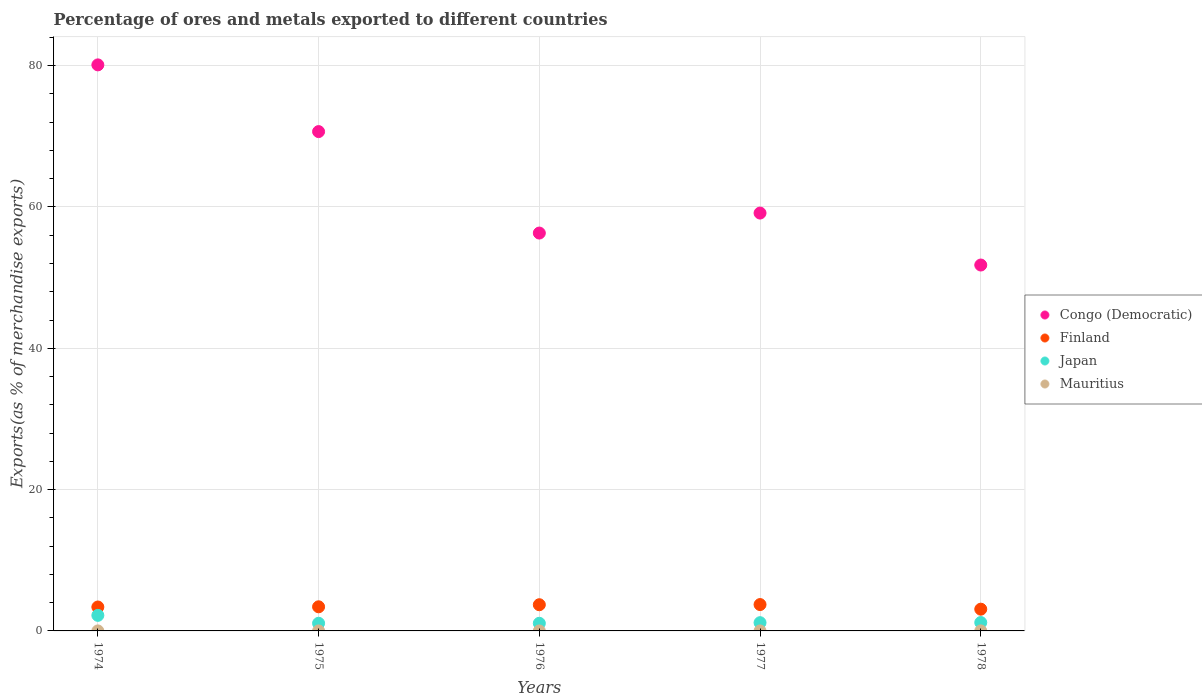Is the number of dotlines equal to the number of legend labels?
Your response must be concise. Yes. What is the percentage of exports to different countries in Finland in 1977?
Offer a very short reply. 3.73. Across all years, what is the maximum percentage of exports to different countries in Congo (Democratic)?
Offer a very short reply. 80.11. Across all years, what is the minimum percentage of exports to different countries in Congo (Democratic)?
Ensure brevity in your answer.  51.79. In which year was the percentage of exports to different countries in Finland minimum?
Your answer should be very brief. 1978. What is the total percentage of exports to different countries in Mauritius in the graph?
Offer a very short reply. 0.01. What is the difference between the percentage of exports to different countries in Finland in 1974 and that in 1975?
Your response must be concise. -0.03. What is the difference between the percentage of exports to different countries in Finland in 1975 and the percentage of exports to different countries in Congo (Democratic) in 1976?
Keep it short and to the point. -52.9. What is the average percentage of exports to different countries in Mauritius per year?
Your answer should be compact. 0. In the year 1977, what is the difference between the percentage of exports to different countries in Mauritius and percentage of exports to different countries in Congo (Democratic)?
Ensure brevity in your answer.  -59.14. What is the ratio of the percentage of exports to different countries in Mauritius in 1974 to that in 1977?
Offer a terse response. 0.18. Is the difference between the percentage of exports to different countries in Mauritius in 1974 and 1976 greater than the difference between the percentage of exports to different countries in Congo (Democratic) in 1974 and 1976?
Keep it short and to the point. No. What is the difference between the highest and the second highest percentage of exports to different countries in Japan?
Provide a short and direct response. 1.01. What is the difference between the highest and the lowest percentage of exports to different countries in Mauritius?
Keep it short and to the point. 0. Is the sum of the percentage of exports to different countries in Finland in 1975 and 1978 greater than the maximum percentage of exports to different countries in Japan across all years?
Your answer should be compact. Yes. Is it the case that in every year, the sum of the percentage of exports to different countries in Japan and percentage of exports to different countries in Finland  is greater than the sum of percentage of exports to different countries in Mauritius and percentage of exports to different countries in Congo (Democratic)?
Your answer should be compact. No. Is it the case that in every year, the sum of the percentage of exports to different countries in Finland and percentage of exports to different countries in Congo (Democratic)  is greater than the percentage of exports to different countries in Mauritius?
Your answer should be very brief. Yes. Does the percentage of exports to different countries in Japan monotonically increase over the years?
Make the answer very short. No. Is the percentage of exports to different countries in Congo (Democratic) strictly less than the percentage of exports to different countries in Japan over the years?
Your response must be concise. No. How many dotlines are there?
Give a very brief answer. 4. How many years are there in the graph?
Offer a terse response. 5. Are the values on the major ticks of Y-axis written in scientific E-notation?
Offer a very short reply. No. Does the graph contain any zero values?
Offer a terse response. No. Does the graph contain grids?
Provide a short and direct response. Yes. Where does the legend appear in the graph?
Give a very brief answer. Center right. What is the title of the graph?
Keep it short and to the point. Percentage of ores and metals exported to different countries. What is the label or title of the Y-axis?
Your answer should be compact. Exports(as % of merchandise exports). What is the Exports(as % of merchandise exports) of Congo (Democratic) in 1974?
Make the answer very short. 80.11. What is the Exports(as % of merchandise exports) of Finland in 1974?
Keep it short and to the point. 3.39. What is the Exports(as % of merchandise exports) of Japan in 1974?
Provide a short and direct response. 2.2. What is the Exports(as % of merchandise exports) in Mauritius in 1974?
Give a very brief answer. 0. What is the Exports(as % of merchandise exports) of Congo (Democratic) in 1975?
Your answer should be compact. 70.67. What is the Exports(as % of merchandise exports) of Finland in 1975?
Offer a terse response. 3.41. What is the Exports(as % of merchandise exports) in Japan in 1975?
Make the answer very short. 1.08. What is the Exports(as % of merchandise exports) in Mauritius in 1975?
Your answer should be compact. 0. What is the Exports(as % of merchandise exports) of Congo (Democratic) in 1976?
Ensure brevity in your answer.  56.31. What is the Exports(as % of merchandise exports) of Finland in 1976?
Provide a short and direct response. 3.71. What is the Exports(as % of merchandise exports) in Japan in 1976?
Provide a short and direct response. 1.08. What is the Exports(as % of merchandise exports) of Mauritius in 1976?
Give a very brief answer. 1.50016651848355e-5. What is the Exports(as % of merchandise exports) of Congo (Democratic) in 1977?
Offer a terse response. 59.14. What is the Exports(as % of merchandise exports) in Finland in 1977?
Provide a succinct answer. 3.73. What is the Exports(as % of merchandise exports) in Japan in 1977?
Your response must be concise. 1.17. What is the Exports(as % of merchandise exports) in Mauritius in 1977?
Your answer should be very brief. 0. What is the Exports(as % of merchandise exports) in Congo (Democratic) in 1978?
Provide a succinct answer. 51.79. What is the Exports(as % of merchandise exports) of Finland in 1978?
Offer a very short reply. 3.08. What is the Exports(as % of merchandise exports) of Japan in 1978?
Provide a succinct answer. 1.19. What is the Exports(as % of merchandise exports) in Mauritius in 1978?
Offer a terse response. 0. Across all years, what is the maximum Exports(as % of merchandise exports) of Congo (Democratic)?
Give a very brief answer. 80.11. Across all years, what is the maximum Exports(as % of merchandise exports) in Finland?
Offer a very short reply. 3.73. Across all years, what is the maximum Exports(as % of merchandise exports) of Japan?
Your answer should be very brief. 2.2. Across all years, what is the maximum Exports(as % of merchandise exports) of Mauritius?
Offer a terse response. 0. Across all years, what is the minimum Exports(as % of merchandise exports) of Congo (Democratic)?
Keep it short and to the point. 51.79. Across all years, what is the minimum Exports(as % of merchandise exports) in Finland?
Provide a short and direct response. 3.08. Across all years, what is the minimum Exports(as % of merchandise exports) of Japan?
Offer a very short reply. 1.08. Across all years, what is the minimum Exports(as % of merchandise exports) in Mauritius?
Give a very brief answer. 1.50016651848355e-5. What is the total Exports(as % of merchandise exports) of Congo (Democratic) in the graph?
Provide a succinct answer. 318.03. What is the total Exports(as % of merchandise exports) in Finland in the graph?
Offer a terse response. 17.32. What is the total Exports(as % of merchandise exports) in Japan in the graph?
Offer a terse response. 6.72. What is the total Exports(as % of merchandise exports) in Mauritius in the graph?
Ensure brevity in your answer.  0.01. What is the difference between the Exports(as % of merchandise exports) in Congo (Democratic) in 1974 and that in 1975?
Your response must be concise. 9.44. What is the difference between the Exports(as % of merchandise exports) in Finland in 1974 and that in 1975?
Your answer should be compact. -0.03. What is the difference between the Exports(as % of merchandise exports) of Japan in 1974 and that in 1975?
Ensure brevity in your answer.  1.12. What is the difference between the Exports(as % of merchandise exports) in Mauritius in 1974 and that in 1975?
Provide a succinct answer. 0. What is the difference between the Exports(as % of merchandise exports) of Congo (Democratic) in 1974 and that in 1976?
Your response must be concise. 23.8. What is the difference between the Exports(as % of merchandise exports) of Finland in 1974 and that in 1976?
Offer a terse response. -0.32. What is the difference between the Exports(as % of merchandise exports) in Japan in 1974 and that in 1976?
Provide a short and direct response. 1.12. What is the difference between the Exports(as % of merchandise exports) in Mauritius in 1974 and that in 1976?
Your response must be concise. 0. What is the difference between the Exports(as % of merchandise exports) of Congo (Democratic) in 1974 and that in 1977?
Offer a terse response. 20.97. What is the difference between the Exports(as % of merchandise exports) in Finland in 1974 and that in 1977?
Offer a terse response. -0.35. What is the difference between the Exports(as % of merchandise exports) of Japan in 1974 and that in 1977?
Provide a short and direct response. 1.03. What is the difference between the Exports(as % of merchandise exports) of Mauritius in 1974 and that in 1977?
Make the answer very short. -0. What is the difference between the Exports(as % of merchandise exports) of Congo (Democratic) in 1974 and that in 1978?
Your answer should be very brief. 28.33. What is the difference between the Exports(as % of merchandise exports) of Finland in 1974 and that in 1978?
Ensure brevity in your answer.  0.31. What is the difference between the Exports(as % of merchandise exports) of Japan in 1974 and that in 1978?
Your answer should be very brief. 1.01. What is the difference between the Exports(as % of merchandise exports) of Mauritius in 1974 and that in 1978?
Your answer should be very brief. -0. What is the difference between the Exports(as % of merchandise exports) of Congo (Democratic) in 1975 and that in 1976?
Your answer should be very brief. 14.36. What is the difference between the Exports(as % of merchandise exports) in Finland in 1975 and that in 1976?
Provide a succinct answer. -0.29. What is the difference between the Exports(as % of merchandise exports) of Japan in 1975 and that in 1976?
Give a very brief answer. 0. What is the difference between the Exports(as % of merchandise exports) of Congo (Democratic) in 1975 and that in 1977?
Provide a succinct answer. 11.53. What is the difference between the Exports(as % of merchandise exports) in Finland in 1975 and that in 1977?
Offer a very short reply. -0.32. What is the difference between the Exports(as % of merchandise exports) of Japan in 1975 and that in 1977?
Your answer should be very brief. -0.08. What is the difference between the Exports(as % of merchandise exports) of Mauritius in 1975 and that in 1977?
Your response must be concise. -0. What is the difference between the Exports(as % of merchandise exports) in Congo (Democratic) in 1975 and that in 1978?
Your answer should be very brief. 18.88. What is the difference between the Exports(as % of merchandise exports) in Finland in 1975 and that in 1978?
Offer a very short reply. 0.34. What is the difference between the Exports(as % of merchandise exports) in Japan in 1975 and that in 1978?
Make the answer very short. -0.1. What is the difference between the Exports(as % of merchandise exports) in Mauritius in 1975 and that in 1978?
Provide a short and direct response. -0. What is the difference between the Exports(as % of merchandise exports) in Congo (Democratic) in 1976 and that in 1977?
Offer a terse response. -2.83. What is the difference between the Exports(as % of merchandise exports) in Finland in 1976 and that in 1977?
Provide a short and direct response. -0.02. What is the difference between the Exports(as % of merchandise exports) in Japan in 1976 and that in 1977?
Give a very brief answer. -0.09. What is the difference between the Exports(as % of merchandise exports) of Mauritius in 1976 and that in 1977?
Ensure brevity in your answer.  -0. What is the difference between the Exports(as % of merchandise exports) in Congo (Democratic) in 1976 and that in 1978?
Offer a terse response. 4.52. What is the difference between the Exports(as % of merchandise exports) in Finland in 1976 and that in 1978?
Your answer should be compact. 0.63. What is the difference between the Exports(as % of merchandise exports) of Japan in 1976 and that in 1978?
Give a very brief answer. -0.11. What is the difference between the Exports(as % of merchandise exports) in Mauritius in 1976 and that in 1978?
Offer a very short reply. -0. What is the difference between the Exports(as % of merchandise exports) in Congo (Democratic) in 1977 and that in 1978?
Your answer should be compact. 7.35. What is the difference between the Exports(as % of merchandise exports) in Finland in 1977 and that in 1978?
Ensure brevity in your answer.  0.65. What is the difference between the Exports(as % of merchandise exports) in Japan in 1977 and that in 1978?
Offer a terse response. -0.02. What is the difference between the Exports(as % of merchandise exports) of Mauritius in 1977 and that in 1978?
Offer a terse response. -0. What is the difference between the Exports(as % of merchandise exports) in Congo (Democratic) in 1974 and the Exports(as % of merchandise exports) in Finland in 1975?
Your answer should be very brief. 76.7. What is the difference between the Exports(as % of merchandise exports) of Congo (Democratic) in 1974 and the Exports(as % of merchandise exports) of Japan in 1975?
Ensure brevity in your answer.  79.03. What is the difference between the Exports(as % of merchandise exports) of Congo (Democratic) in 1974 and the Exports(as % of merchandise exports) of Mauritius in 1975?
Ensure brevity in your answer.  80.11. What is the difference between the Exports(as % of merchandise exports) in Finland in 1974 and the Exports(as % of merchandise exports) in Japan in 1975?
Provide a short and direct response. 2.3. What is the difference between the Exports(as % of merchandise exports) in Finland in 1974 and the Exports(as % of merchandise exports) in Mauritius in 1975?
Offer a terse response. 3.38. What is the difference between the Exports(as % of merchandise exports) of Japan in 1974 and the Exports(as % of merchandise exports) of Mauritius in 1975?
Offer a very short reply. 2.2. What is the difference between the Exports(as % of merchandise exports) in Congo (Democratic) in 1974 and the Exports(as % of merchandise exports) in Finland in 1976?
Your response must be concise. 76.41. What is the difference between the Exports(as % of merchandise exports) of Congo (Democratic) in 1974 and the Exports(as % of merchandise exports) of Japan in 1976?
Keep it short and to the point. 79.03. What is the difference between the Exports(as % of merchandise exports) of Congo (Democratic) in 1974 and the Exports(as % of merchandise exports) of Mauritius in 1976?
Make the answer very short. 80.11. What is the difference between the Exports(as % of merchandise exports) in Finland in 1974 and the Exports(as % of merchandise exports) in Japan in 1976?
Give a very brief answer. 2.3. What is the difference between the Exports(as % of merchandise exports) of Finland in 1974 and the Exports(as % of merchandise exports) of Mauritius in 1976?
Keep it short and to the point. 3.38. What is the difference between the Exports(as % of merchandise exports) in Japan in 1974 and the Exports(as % of merchandise exports) in Mauritius in 1976?
Offer a terse response. 2.2. What is the difference between the Exports(as % of merchandise exports) in Congo (Democratic) in 1974 and the Exports(as % of merchandise exports) in Finland in 1977?
Offer a very short reply. 76.38. What is the difference between the Exports(as % of merchandise exports) of Congo (Democratic) in 1974 and the Exports(as % of merchandise exports) of Japan in 1977?
Offer a very short reply. 78.95. What is the difference between the Exports(as % of merchandise exports) of Congo (Democratic) in 1974 and the Exports(as % of merchandise exports) of Mauritius in 1977?
Offer a very short reply. 80.11. What is the difference between the Exports(as % of merchandise exports) in Finland in 1974 and the Exports(as % of merchandise exports) in Japan in 1977?
Ensure brevity in your answer.  2.22. What is the difference between the Exports(as % of merchandise exports) of Finland in 1974 and the Exports(as % of merchandise exports) of Mauritius in 1977?
Offer a very short reply. 3.38. What is the difference between the Exports(as % of merchandise exports) of Japan in 1974 and the Exports(as % of merchandise exports) of Mauritius in 1977?
Offer a very short reply. 2.2. What is the difference between the Exports(as % of merchandise exports) in Congo (Democratic) in 1974 and the Exports(as % of merchandise exports) in Finland in 1978?
Your answer should be very brief. 77.04. What is the difference between the Exports(as % of merchandise exports) of Congo (Democratic) in 1974 and the Exports(as % of merchandise exports) of Japan in 1978?
Offer a very short reply. 78.93. What is the difference between the Exports(as % of merchandise exports) in Congo (Democratic) in 1974 and the Exports(as % of merchandise exports) in Mauritius in 1978?
Provide a short and direct response. 80.11. What is the difference between the Exports(as % of merchandise exports) in Finland in 1974 and the Exports(as % of merchandise exports) in Japan in 1978?
Provide a succinct answer. 2.2. What is the difference between the Exports(as % of merchandise exports) of Finland in 1974 and the Exports(as % of merchandise exports) of Mauritius in 1978?
Keep it short and to the point. 3.38. What is the difference between the Exports(as % of merchandise exports) of Japan in 1974 and the Exports(as % of merchandise exports) of Mauritius in 1978?
Your answer should be compact. 2.2. What is the difference between the Exports(as % of merchandise exports) in Congo (Democratic) in 1975 and the Exports(as % of merchandise exports) in Finland in 1976?
Offer a very short reply. 66.96. What is the difference between the Exports(as % of merchandise exports) in Congo (Democratic) in 1975 and the Exports(as % of merchandise exports) in Japan in 1976?
Ensure brevity in your answer.  69.59. What is the difference between the Exports(as % of merchandise exports) in Congo (Democratic) in 1975 and the Exports(as % of merchandise exports) in Mauritius in 1976?
Your response must be concise. 70.67. What is the difference between the Exports(as % of merchandise exports) of Finland in 1975 and the Exports(as % of merchandise exports) of Japan in 1976?
Keep it short and to the point. 2.33. What is the difference between the Exports(as % of merchandise exports) in Finland in 1975 and the Exports(as % of merchandise exports) in Mauritius in 1976?
Make the answer very short. 3.41. What is the difference between the Exports(as % of merchandise exports) in Japan in 1975 and the Exports(as % of merchandise exports) in Mauritius in 1976?
Your answer should be compact. 1.08. What is the difference between the Exports(as % of merchandise exports) in Congo (Democratic) in 1975 and the Exports(as % of merchandise exports) in Finland in 1977?
Offer a very short reply. 66.94. What is the difference between the Exports(as % of merchandise exports) of Congo (Democratic) in 1975 and the Exports(as % of merchandise exports) of Japan in 1977?
Offer a terse response. 69.5. What is the difference between the Exports(as % of merchandise exports) in Congo (Democratic) in 1975 and the Exports(as % of merchandise exports) in Mauritius in 1977?
Keep it short and to the point. 70.67. What is the difference between the Exports(as % of merchandise exports) in Finland in 1975 and the Exports(as % of merchandise exports) in Japan in 1977?
Offer a terse response. 2.25. What is the difference between the Exports(as % of merchandise exports) in Finland in 1975 and the Exports(as % of merchandise exports) in Mauritius in 1977?
Give a very brief answer. 3.41. What is the difference between the Exports(as % of merchandise exports) in Japan in 1975 and the Exports(as % of merchandise exports) in Mauritius in 1977?
Your response must be concise. 1.08. What is the difference between the Exports(as % of merchandise exports) in Congo (Democratic) in 1975 and the Exports(as % of merchandise exports) in Finland in 1978?
Provide a succinct answer. 67.59. What is the difference between the Exports(as % of merchandise exports) of Congo (Democratic) in 1975 and the Exports(as % of merchandise exports) of Japan in 1978?
Your response must be concise. 69.48. What is the difference between the Exports(as % of merchandise exports) of Congo (Democratic) in 1975 and the Exports(as % of merchandise exports) of Mauritius in 1978?
Give a very brief answer. 70.67. What is the difference between the Exports(as % of merchandise exports) in Finland in 1975 and the Exports(as % of merchandise exports) in Japan in 1978?
Your response must be concise. 2.23. What is the difference between the Exports(as % of merchandise exports) in Finland in 1975 and the Exports(as % of merchandise exports) in Mauritius in 1978?
Make the answer very short. 3.41. What is the difference between the Exports(as % of merchandise exports) of Japan in 1975 and the Exports(as % of merchandise exports) of Mauritius in 1978?
Offer a terse response. 1.08. What is the difference between the Exports(as % of merchandise exports) in Congo (Democratic) in 1976 and the Exports(as % of merchandise exports) in Finland in 1977?
Offer a terse response. 52.58. What is the difference between the Exports(as % of merchandise exports) of Congo (Democratic) in 1976 and the Exports(as % of merchandise exports) of Japan in 1977?
Your answer should be very brief. 55.14. What is the difference between the Exports(as % of merchandise exports) in Congo (Democratic) in 1976 and the Exports(as % of merchandise exports) in Mauritius in 1977?
Offer a terse response. 56.31. What is the difference between the Exports(as % of merchandise exports) of Finland in 1976 and the Exports(as % of merchandise exports) of Japan in 1977?
Your answer should be very brief. 2.54. What is the difference between the Exports(as % of merchandise exports) in Finland in 1976 and the Exports(as % of merchandise exports) in Mauritius in 1977?
Keep it short and to the point. 3.71. What is the difference between the Exports(as % of merchandise exports) of Japan in 1976 and the Exports(as % of merchandise exports) of Mauritius in 1977?
Ensure brevity in your answer.  1.08. What is the difference between the Exports(as % of merchandise exports) in Congo (Democratic) in 1976 and the Exports(as % of merchandise exports) in Finland in 1978?
Offer a very short reply. 53.23. What is the difference between the Exports(as % of merchandise exports) in Congo (Democratic) in 1976 and the Exports(as % of merchandise exports) in Japan in 1978?
Offer a terse response. 55.12. What is the difference between the Exports(as % of merchandise exports) in Congo (Democratic) in 1976 and the Exports(as % of merchandise exports) in Mauritius in 1978?
Make the answer very short. 56.31. What is the difference between the Exports(as % of merchandise exports) of Finland in 1976 and the Exports(as % of merchandise exports) of Japan in 1978?
Your answer should be compact. 2.52. What is the difference between the Exports(as % of merchandise exports) in Finland in 1976 and the Exports(as % of merchandise exports) in Mauritius in 1978?
Your answer should be very brief. 3.7. What is the difference between the Exports(as % of merchandise exports) in Japan in 1976 and the Exports(as % of merchandise exports) in Mauritius in 1978?
Make the answer very short. 1.08. What is the difference between the Exports(as % of merchandise exports) in Congo (Democratic) in 1977 and the Exports(as % of merchandise exports) in Finland in 1978?
Offer a very short reply. 56.06. What is the difference between the Exports(as % of merchandise exports) in Congo (Democratic) in 1977 and the Exports(as % of merchandise exports) in Japan in 1978?
Give a very brief answer. 57.95. What is the difference between the Exports(as % of merchandise exports) of Congo (Democratic) in 1977 and the Exports(as % of merchandise exports) of Mauritius in 1978?
Your answer should be very brief. 59.14. What is the difference between the Exports(as % of merchandise exports) of Finland in 1977 and the Exports(as % of merchandise exports) of Japan in 1978?
Your answer should be very brief. 2.54. What is the difference between the Exports(as % of merchandise exports) of Finland in 1977 and the Exports(as % of merchandise exports) of Mauritius in 1978?
Your answer should be compact. 3.73. What is the difference between the Exports(as % of merchandise exports) in Japan in 1977 and the Exports(as % of merchandise exports) in Mauritius in 1978?
Ensure brevity in your answer.  1.16. What is the average Exports(as % of merchandise exports) in Congo (Democratic) per year?
Provide a succinct answer. 63.61. What is the average Exports(as % of merchandise exports) in Finland per year?
Make the answer very short. 3.46. What is the average Exports(as % of merchandise exports) in Japan per year?
Keep it short and to the point. 1.34. What is the average Exports(as % of merchandise exports) in Mauritius per year?
Give a very brief answer. 0. In the year 1974, what is the difference between the Exports(as % of merchandise exports) of Congo (Democratic) and Exports(as % of merchandise exports) of Finland?
Provide a short and direct response. 76.73. In the year 1974, what is the difference between the Exports(as % of merchandise exports) of Congo (Democratic) and Exports(as % of merchandise exports) of Japan?
Provide a short and direct response. 77.91. In the year 1974, what is the difference between the Exports(as % of merchandise exports) of Congo (Democratic) and Exports(as % of merchandise exports) of Mauritius?
Give a very brief answer. 80.11. In the year 1974, what is the difference between the Exports(as % of merchandise exports) of Finland and Exports(as % of merchandise exports) of Japan?
Ensure brevity in your answer.  1.18. In the year 1974, what is the difference between the Exports(as % of merchandise exports) in Finland and Exports(as % of merchandise exports) in Mauritius?
Offer a very short reply. 3.38. In the year 1974, what is the difference between the Exports(as % of merchandise exports) of Japan and Exports(as % of merchandise exports) of Mauritius?
Offer a terse response. 2.2. In the year 1975, what is the difference between the Exports(as % of merchandise exports) in Congo (Democratic) and Exports(as % of merchandise exports) in Finland?
Give a very brief answer. 67.26. In the year 1975, what is the difference between the Exports(as % of merchandise exports) of Congo (Democratic) and Exports(as % of merchandise exports) of Japan?
Offer a terse response. 69.59. In the year 1975, what is the difference between the Exports(as % of merchandise exports) in Congo (Democratic) and Exports(as % of merchandise exports) in Mauritius?
Keep it short and to the point. 70.67. In the year 1975, what is the difference between the Exports(as % of merchandise exports) of Finland and Exports(as % of merchandise exports) of Japan?
Make the answer very short. 2.33. In the year 1975, what is the difference between the Exports(as % of merchandise exports) in Finland and Exports(as % of merchandise exports) in Mauritius?
Keep it short and to the point. 3.41. In the year 1975, what is the difference between the Exports(as % of merchandise exports) of Japan and Exports(as % of merchandise exports) of Mauritius?
Ensure brevity in your answer.  1.08. In the year 1976, what is the difference between the Exports(as % of merchandise exports) in Congo (Democratic) and Exports(as % of merchandise exports) in Finland?
Provide a succinct answer. 52.6. In the year 1976, what is the difference between the Exports(as % of merchandise exports) of Congo (Democratic) and Exports(as % of merchandise exports) of Japan?
Your answer should be compact. 55.23. In the year 1976, what is the difference between the Exports(as % of merchandise exports) of Congo (Democratic) and Exports(as % of merchandise exports) of Mauritius?
Your response must be concise. 56.31. In the year 1976, what is the difference between the Exports(as % of merchandise exports) of Finland and Exports(as % of merchandise exports) of Japan?
Offer a very short reply. 2.63. In the year 1976, what is the difference between the Exports(as % of merchandise exports) of Finland and Exports(as % of merchandise exports) of Mauritius?
Your answer should be compact. 3.71. In the year 1976, what is the difference between the Exports(as % of merchandise exports) of Japan and Exports(as % of merchandise exports) of Mauritius?
Provide a short and direct response. 1.08. In the year 1977, what is the difference between the Exports(as % of merchandise exports) in Congo (Democratic) and Exports(as % of merchandise exports) in Finland?
Your answer should be compact. 55.41. In the year 1977, what is the difference between the Exports(as % of merchandise exports) in Congo (Democratic) and Exports(as % of merchandise exports) in Japan?
Your answer should be very brief. 57.97. In the year 1977, what is the difference between the Exports(as % of merchandise exports) of Congo (Democratic) and Exports(as % of merchandise exports) of Mauritius?
Your response must be concise. 59.14. In the year 1977, what is the difference between the Exports(as % of merchandise exports) in Finland and Exports(as % of merchandise exports) in Japan?
Provide a short and direct response. 2.56. In the year 1977, what is the difference between the Exports(as % of merchandise exports) of Finland and Exports(as % of merchandise exports) of Mauritius?
Offer a very short reply. 3.73. In the year 1977, what is the difference between the Exports(as % of merchandise exports) of Japan and Exports(as % of merchandise exports) of Mauritius?
Offer a terse response. 1.17. In the year 1978, what is the difference between the Exports(as % of merchandise exports) in Congo (Democratic) and Exports(as % of merchandise exports) in Finland?
Give a very brief answer. 48.71. In the year 1978, what is the difference between the Exports(as % of merchandise exports) of Congo (Democratic) and Exports(as % of merchandise exports) of Japan?
Provide a succinct answer. 50.6. In the year 1978, what is the difference between the Exports(as % of merchandise exports) in Congo (Democratic) and Exports(as % of merchandise exports) in Mauritius?
Your answer should be compact. 51.78. In the year 1978, what is the difference between the Exports(as % of merchandise exports) in Finland and Exports(as % of merchandise exports) in Japan?
Keep it short and to the point. 1.89. In the year 1978, what is the difference between the Exports(as % of merchandise exports) in Finland and Exports(as % of merchandise exports) in Mauritius?
Your answer should be very brief. 3.07. In the year 1978, what is the difference between the Exports(as % of merchandise exports) of Japan and Exports(as % of merchandise exports) of Mauritius?
Provide a succinct answer. 1.18. What is the ratio of the Exports(as % of merchandise exports) of Congo (Democratic) in 1974 to that in 1975?
Offer a terse response. 1.13. What is the ratio of the Exports(as % of merchandise exports) of Japan in 1974 to that in 1975?
Give a very brief answer. 2.03. What is the ratio of the Exports(as % of merchandise exports) of Mauritius in 1974 to that in 1975?
Offer a very short reply. 1.04. What is the ratio of the Exports(as % of merchandise exports) in Congo (Democratic) in 1974 to that in 1976?
Give a very brief answer. 1.42. What is the ratio of the Exports(as % of merchandise exports) of Finland in 1974 to that in 1976?
Your response must be concise. 0.91. What is the ratio of the Exports(as % of merchandise exports) of Japan in 1974 to that in 1976?
Ensure brevity in your answer.  2.04. What is the ratio of the Exports(as % of merchandise exports) in Mauritius in 1974 to that in 1976?
Offer a terse response. 22.42. What is the ratio of the Exports(as % of merchandise exports) of Congo (Democratic) in 1974 to that in 1977?
Give a very brief answer. 1.35. What is the ratio of the Exports(as % of merchandise exports) of Finland in 1974 to that in 1977?
Ensure brevity in your answer.  0.91. What is the ratio of the Exports(as % of merchandise exports) of Japan in 1974 to that in 1977?
Provide a succinct answer. 1.89. What is the ratio of the Exports(as % of merchandise exports) in Mauritius in 1974 to that in 1977?
Your answer should be compact. 0.18. What is the ratio of the Exports(as % of merchandise exports) of Congo (Democratic) in 1974 to that in 1978?
Provide a succinct answer. 1.55. What is the ratio of the Exports(as % of merchandise exports) in Finland in 1974 to that in 1978?
Your answer should be compact. 1.1. What is the ratio of the Exports(as % of merchandise exports) in Japan in 1974 to that in 1978?
Your answer should be very brief. 1.85. What is the ratio of the Exports(as % of merchandise exports) in Mauritius in 1974 to that in 1978?
Provide a short and direct response. 0.07. What is the ratio of the Exports(as % of merchandise exports) in Congo (Democratic) in 1975 to that in 1976?
Your answer should be compact. 1.25. What is the ratio of the Exports(as % of merchandise exports) in Finland in 1975 to that in 1976?
Offer a terse response. 0.92. What is the ratio of the Exports(as % of merchandise exports) in Mauritius in 1975 to that in 1976?
Ensure brevity in your answer.  21.63. What is the ratio of the Exports(as % of merchandise exports) of Congo (Democratic) in 1975 to that in 1977?
Your answer should be compact. 1.2. What is the ratio of the Exports(as % of merchandise exports) in Finland in 1975 to that in 1977?
Ensure brevity in your answer.  0.91. What is the ratio of the Exports(as % of merchandise exports) of Japan in 1975 to that in 1977?
Ensure brevity in your answer.  0.93. What is the ratio of the Exports(as % of merchandise exports) of Mauritius in 1975 to that in 1977?
Ensure brevity in your answer.  0.17. What is the ratio of the Exports(as % of merchandise exports) in Congo (Democratic) in 1975 to that in 1978?
Your answer should be very brief. 1.36. What is the ratio of the Exports(as % of merchandise exports) in Finland in 1975 to that in 1978?
Your answer should be very brief. 1.11. What is the ratio of the Exports(as % of merchandise exports) of Japan in 1975 to that in 1978?
Offer a very short reply. 0.91. What is the ratio of the Exports(as % of merchandise exports) of Mauritius in 1975 to that in 1978?
Your answer should be compact. 0.07. What is the ratio of the Exports(as % of merchandise exports) of Congo (Democratic) in 1976 to that in 1977?
Ensure brevity in your answer.  0.95. What is the ratio of the Exports(as % of merchandise exports) of Japan in 1976 to that in 1977?
Offer a terse response. 0.93. What is the ratio of the Exports(as % of merchandise exports) in Mauritius in 1976 to that in 1977?
Keep it short and to the point. 0.01. What is the ratio of the Exports(as % of merchandise exports) in Congo (Democratic) in 1976 to that in 1978?
Offer a terse response. 1.09. What is the ratio of the Exports(as % of merchandise exports) of Finland in 1976 to that in 1978?
Keep it short and to the point. 1.2. What is the ratio of the Exports(as % of merchandise exports) in Japan in 1976 to that in 1978?
Provide a short and direct response. 0.91. What is the ratio of the Exports(as % of merchandise exports) in Mauritius in 1976 to that in 1978?
Offer a very short reply. 0. What is the ratio of the Exports(as % of merchandise exports) of Congo (Democratic) in 1977 to that in 1978?
Provide a short and direct response. 1.14. What is the ratio of the Exports(as % of merchandise exports) in Finland in 1977 to that in 1978?
Offer a very short reply. 1.21. What is the ratio of the Exports(as % of merchandise exports) of Japan in 1977 to that in 1978?
Ensure brevity in your answer.  0.98. What is the ratio of the Exports(as % of merchandise exports) of Mauritius in 1977 to that in 1978?
Provide a succinct answer. 0.4. What is the difference between the highest and the second highest Exports(as % of merchandise exports) of Congo (Democratic)?
Provide a short and direct response. 9.44. What is the difference between the highest and the second highest Exports(as % of merchandise exports) of Finland?
Provide a short and direct response. 0.02. What is the difference between the highest and the second highest Exports(as % of merchandise exports) of Japan?
Your answer should be compact. 1.01. What is the difference between the highest and the second highest Exports(as % of merchandise exports) in Mauritius?
Provide a short and direct response. 0. What is the difference between the highest and the lowest Exports(as % of merchandise exports) in Congo (Democratic)?
Your response must be concise. 28.33. What is the difference between the highest and the lowest Exports(as % of merchandise exports) in Finland?
Your answer should be very brief. 0.65. What is the difference between the highest and the lowest Exports(as % of merchandise exports) of Japan?
Provide a short and direct response. 1.12. What is the difference between the highest and the lowest Exports(as % of merchandise exports) of Mauritius?
Keep it short and to the point. 0. 